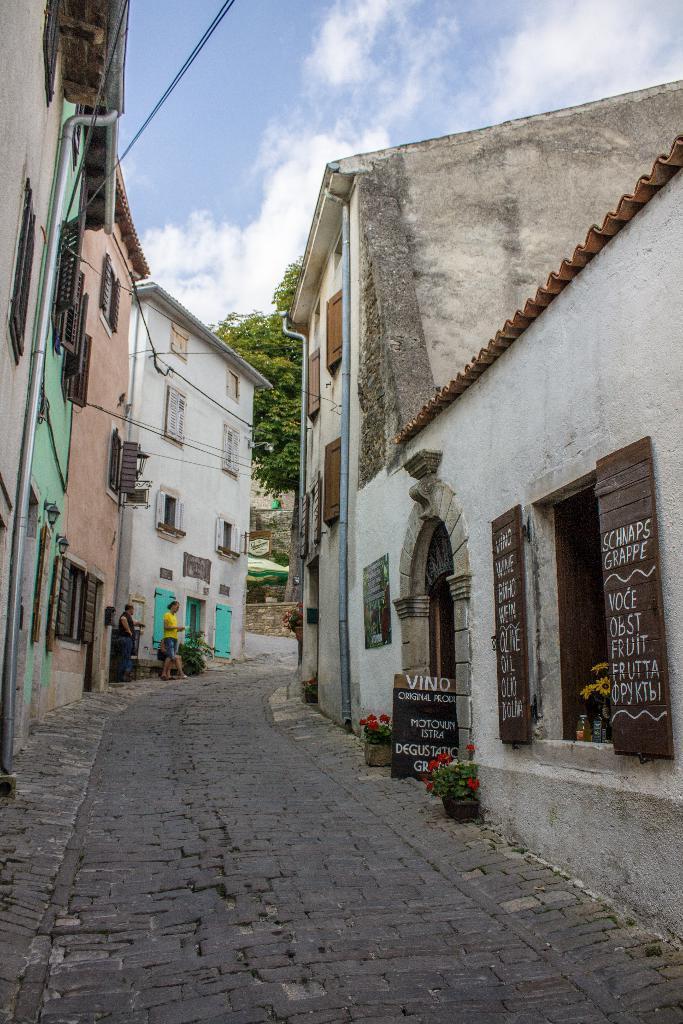How would you summarize this image in a sentence or two? In this picture we can see the road, buildings with windows, pipes, boards, house plants, tree and two persons walking and in the background we can see the sky with clouds. 